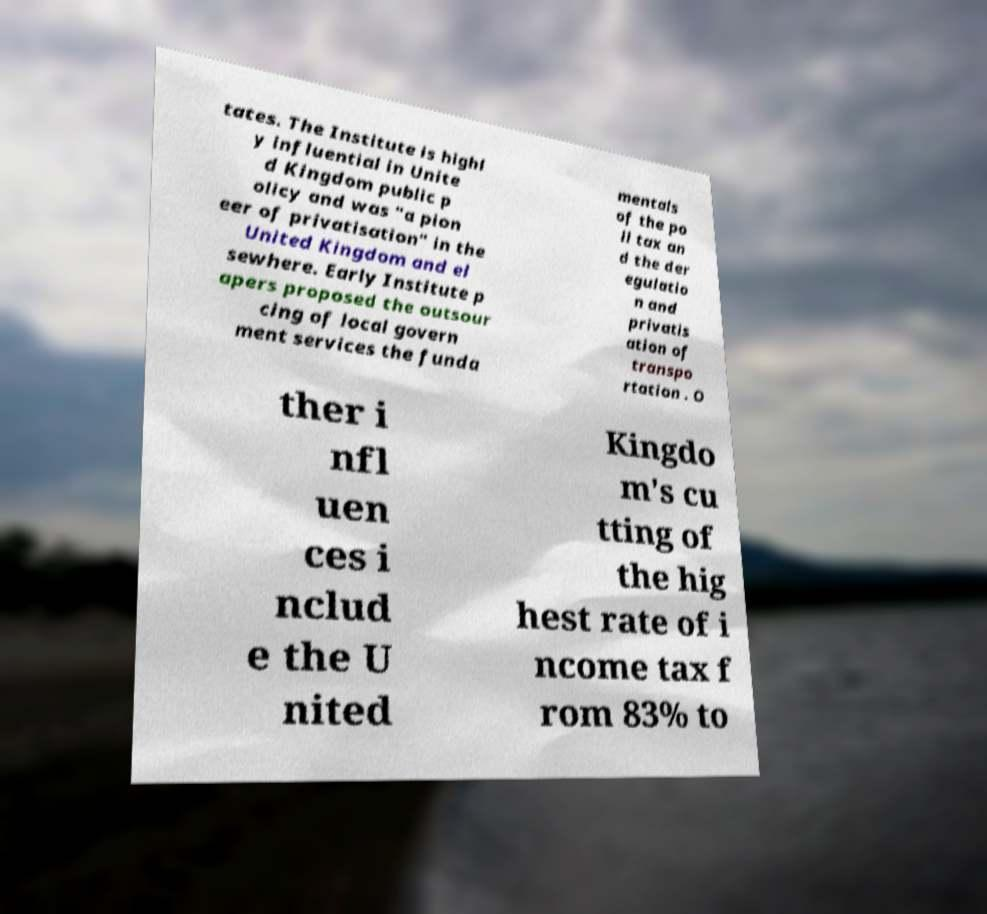I need the written content from this picture converted into text. Can you do that? tates. The Institute is highl y influential in Unite d Kingdom public p olicy and was "a pion eer of privatisation" in the United Kingdom and el sewhere. Early Institute p apers proposed the outsour cing of local govern ment services the funda mentals of the po ll tax an d the der egulatio n and privatis ation of transpo rtation . O ther i nfl uen ces i nclud e the U nited Kingdo m's cu tting of the hig hest rate of i ncome tax f rom 83% to 